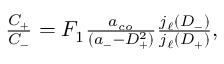<formula> <loc_0><loc_0><loc_500><loc_500>\begin{array} { r } { \frac { C _ { + } } { C _ { - } } = F _ { 1 } \frac { a _ { c o } } { ( a _ { - } - D _ { + } ^ { 2 } ) } \frac { j _ { \ell } ( D _ { - } ) } { j _ { \ell } ( D _ { + } ) } , } \end{array}</formula> 